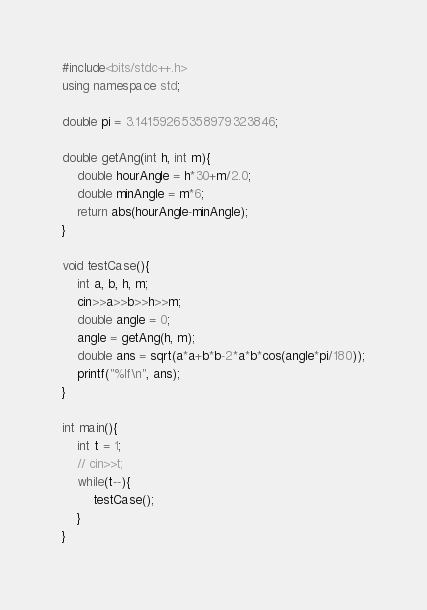<code> <loc_0><loc_0><loc_500><loc_500><_C++_>#include<bits/stdc++.h>
using namespace std;

double pi = 3.14159265358979323846;

double getAng(int h, int m){
    double hourAngle = h*30+m/2.0;
    double minAngle = m*6;
    return abs(hourAngle-minAngle);
}

void testCase(){
	int a, b, h, m;
    cin>>a>>b>>h>>m;
    double angle = 0;
    angle = getAng(h, m);
    double ans = sqrt(a*a+b*b-2*a*b*cos(angle*pi/180));
    printf("%lf\n", ans);
}

int main(){
    int t = 1;
    // cin>>t;
    while(t--){
        testCase();
    }
}
</code> 